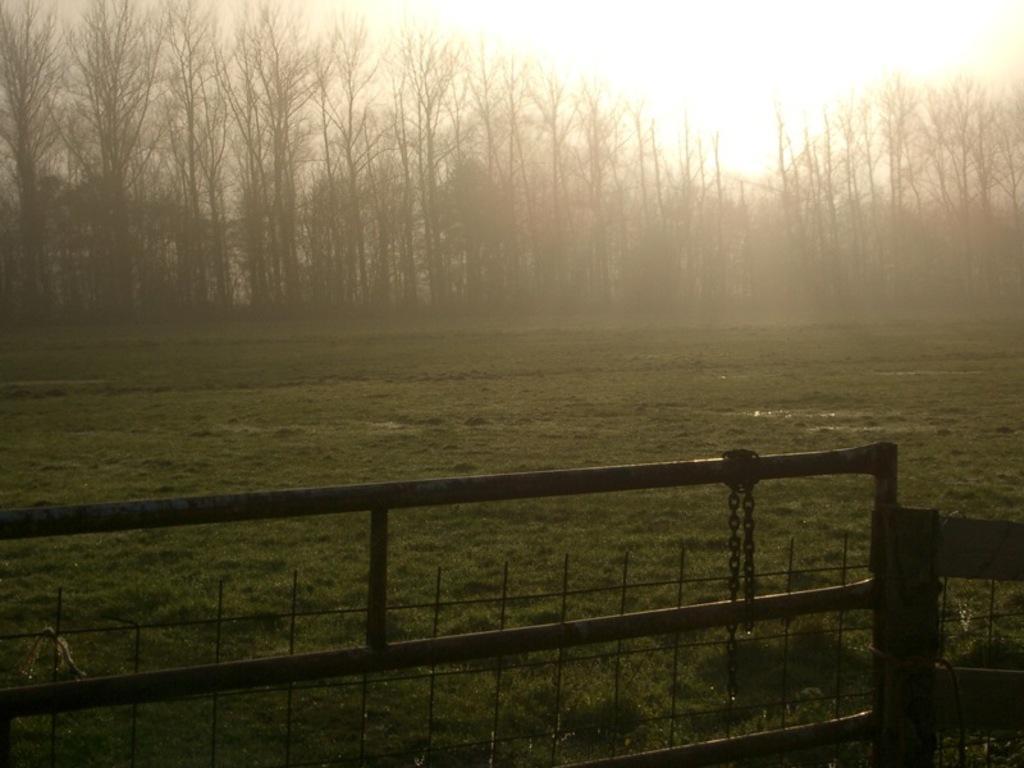Please provide a concise description of this image. In this image we can see a iron gate with chain attached to it and in the background we can see group of trees and sky. 